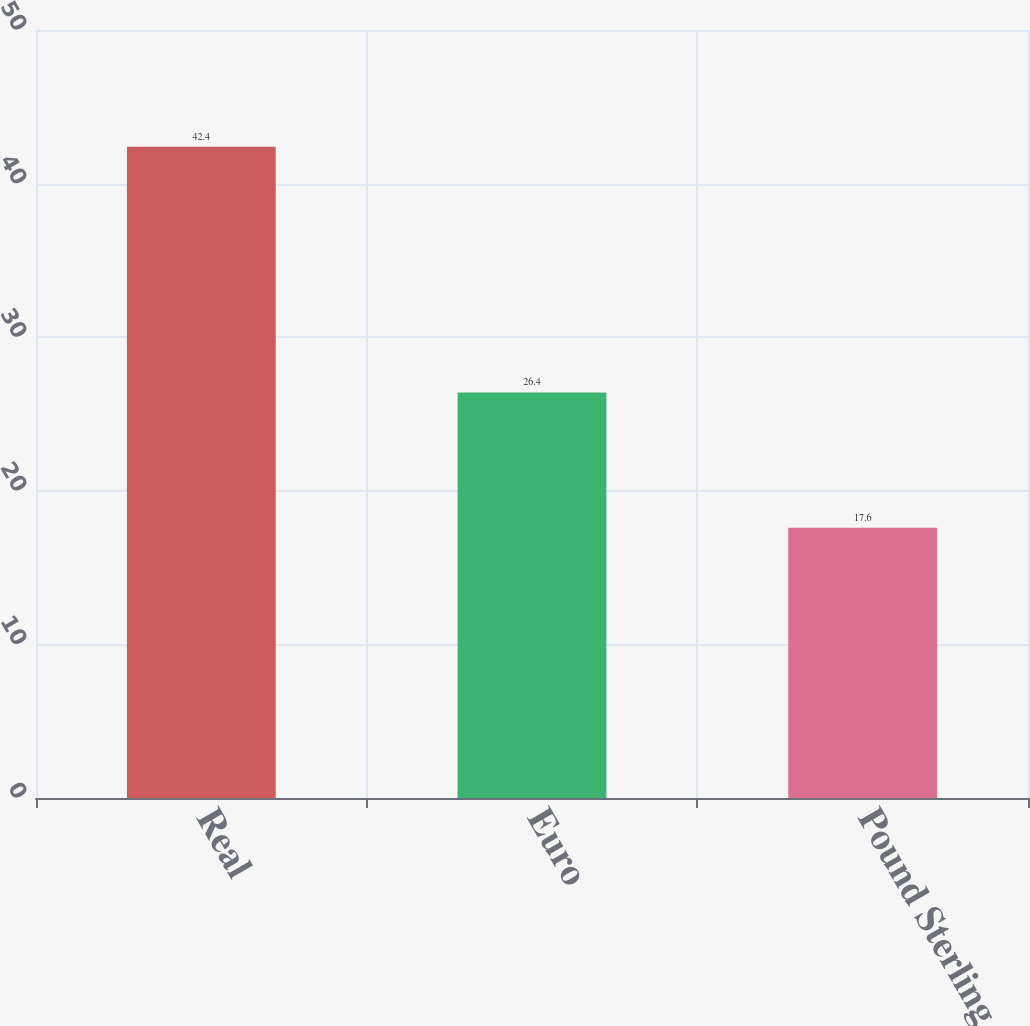Convert chart to OTSL. <chart><loc_0><loc_0><loc_500><loc_500><bar_chart><fcel>Real<fcel>Euro<fcel>Pound Sterling<nl><fcel>42.4<fcel>26.4<fcel>17.6<nl></chart> 